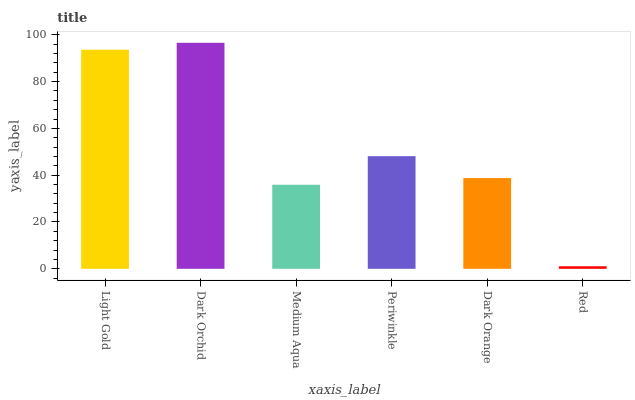Is Red the minimum?
Answer yes or no. Yes. Is Dark Orchid the maximum?
Answer yes or no. Yes. Is Medium Aqua the minimum?
Answer yes or no. No. Is Medium Aqua the maximum?
Answer yes or no. No. Is Dark Orchid greater than Medium Aqua?
Answer yes or no. Yes. Is Medium Aqua less than Dark Orchid?
Answer yes or no. Yes. Is Medium Aqua greater than Dark Orchid?
Answer yes or no. No. Is Dark Orchid less than Medium Aqua?
Answer yes or no. No. Is Periwinkle the high median?
Answer yes or no. Yes. Is Dark Orange the low median?
Answer yes or no. Yes. Is Dark Orange the high median?
Answer yes or no. No. Is Periwinkle the low median?
Answer yes or no. No. 